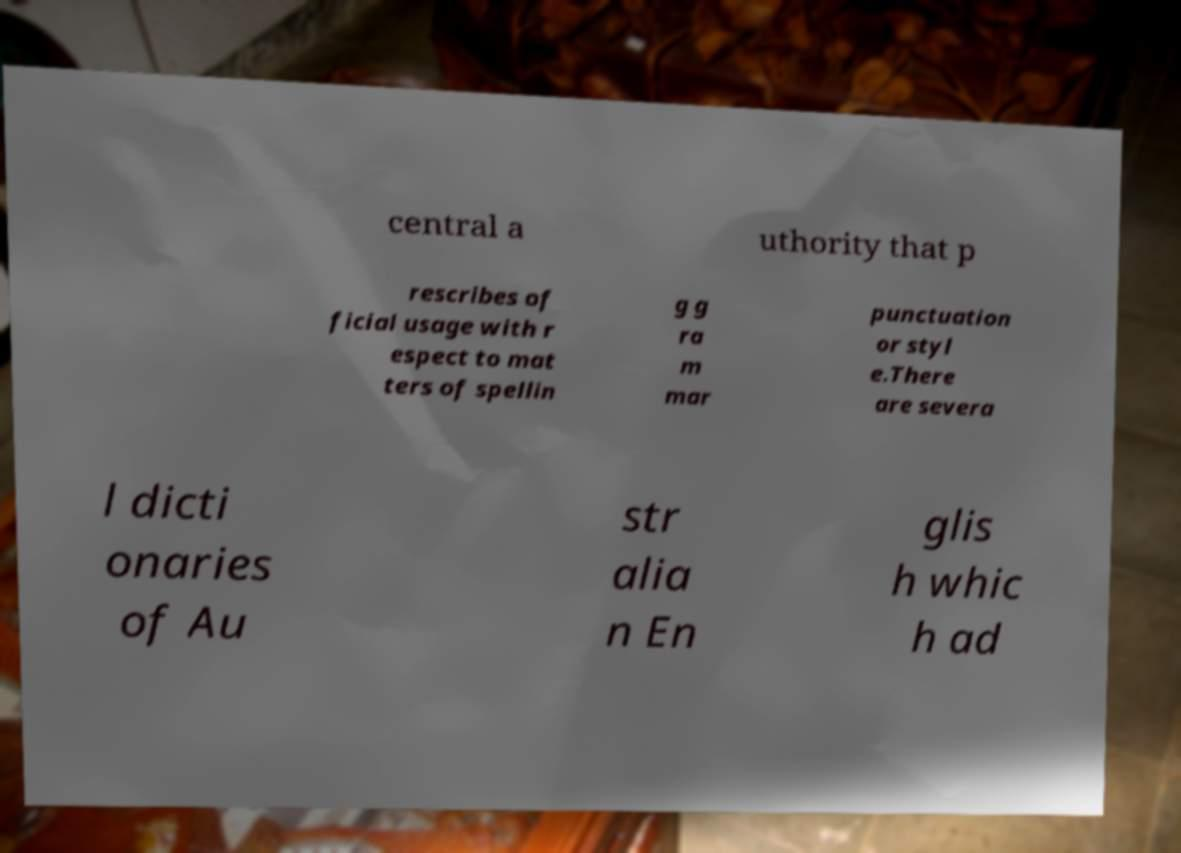I need the written content from this picture converted into text. Can you do that? central a uthority that p rescribes of ficial usage with r espect to mat ters of spellin g g ra m mar punctuation or styl e.There are severa l dicti onaries of Au str alia n En glis h whic h ad 